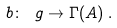Convert formula to latex. <formula><loc_0><loc_0><loc_500><loc_500>b \colon \ g \to \Gamma ( A ) \, .</formula> 